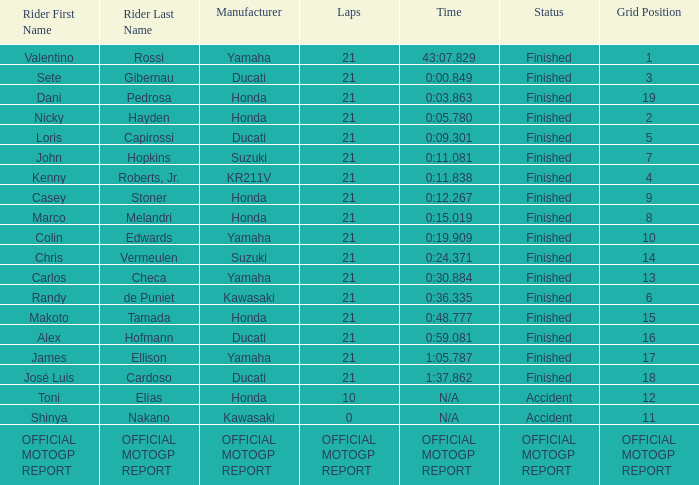How many laps did Valentino rossi have when riding a vehicle manufactured by yamaha? 21.0. 